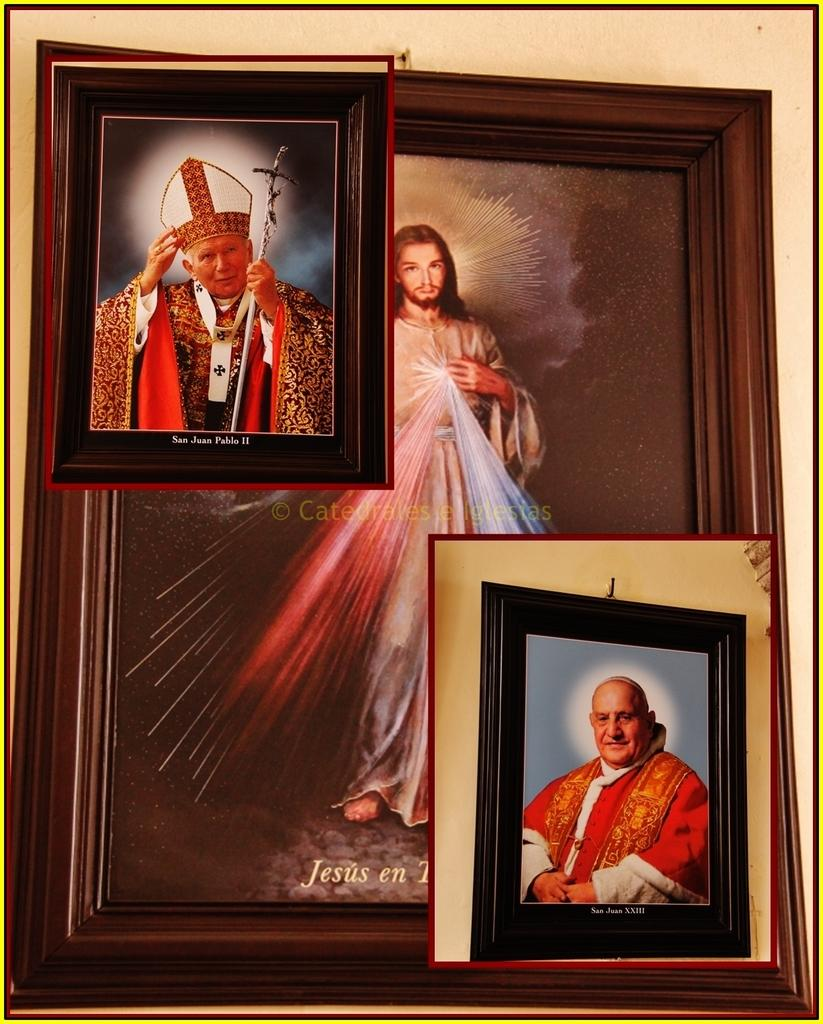<image>
Render a clear and concise summary of the photo. Three pictures are hanging, including one of Jesus and another of a man San Juan Pablo II 